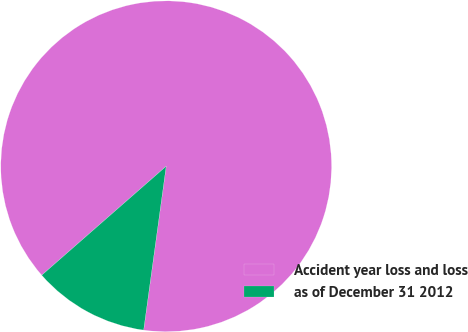Convert chart. <chart><loc_0><loc_0><loc_500><loc_500><pie_chart><fcel>Accident year loss and loss<fcel>as of December 31 2012<nl><fcel>88.62%<fcel>11.38%<nl></chart> 